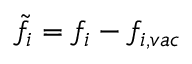<formula> <loc_0><loc_0><loc_500><loc_500>\tilde { f } _ { i } = f _ { i } - f _ { i , v a c }</formula> 